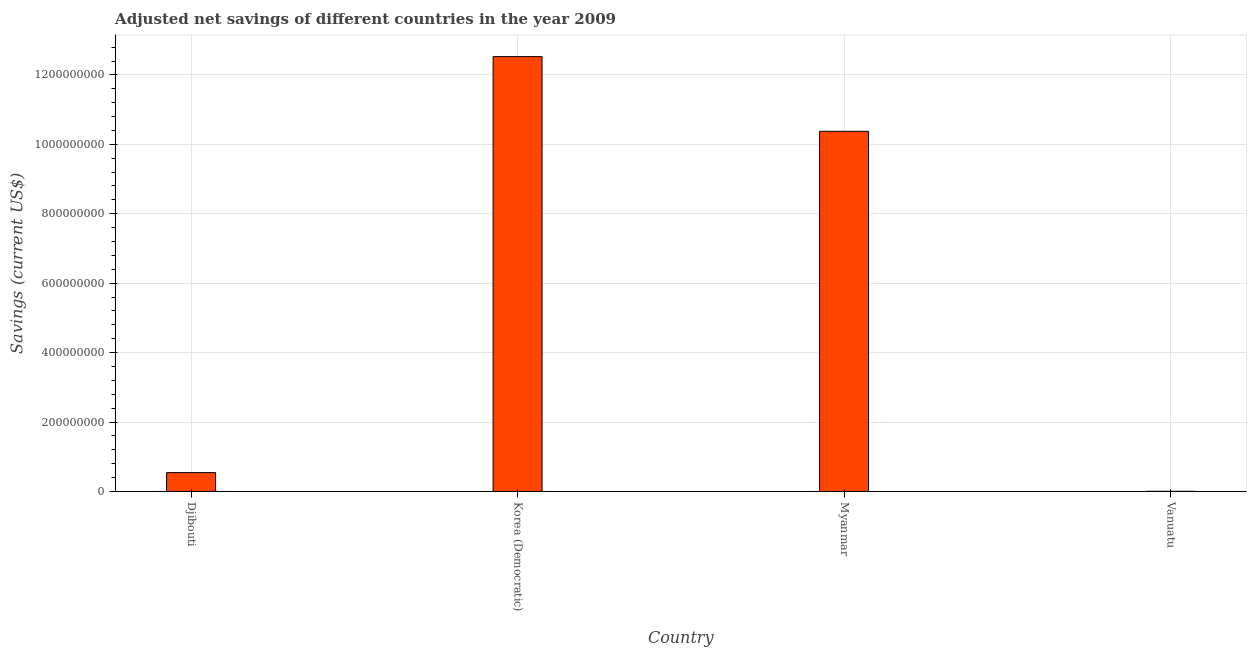Does the graph contain any zero values?
Ensure brevity in your answer.  No. What is the title of the graph?
Ensure brevity in your answer.  Adjusted net savings of different countries in the year 2009. What is the label or title of the Y-axis?
Give a very brief answer. Savings (current US$). What is the adjusted net savings in Vanuatu?
Your answer should be very brief. 5.18e+05. Across all countries, what is the maximum adjusted net savings?
Make the answer very short. 1.25e+09. Across all countries, what is the minimum adjusted net savings?
Offer a very short reply. 5.18e+05. In which country was the adjusted net savings maximum?
Provide a succinct answer. Korea (Democratic). In which country was the adjusted net savings minimum?
Offer a very short reply. Vanuatu. What is the sum of the adjusted net savings?
Make the answer very short. 2.35e+09. What is the difference between the adjusted net savings in Djibouti and Vanuatu?
Make the answer very short. 5.38e+07. What is the average adjusted net savings per country?
Give a very brief answer. 5.86e+08. What is the median adjusted net savings?
Your response must be concise. 5.46e+08. What is the ratio of the adjusted net savings in Korea (Democratic) to that in Myanmar?
Keep it short and to the point. 1.21. Is the difference between the adjusted net savings in Djibouti and Myanmar greater than the difference between any two countries?
Your response must be concise. No. What is the difference between the highest and the second highest adjusted net savings?
Make the answer very short. 2.15e+08. Is the sum of the adjusted net savings in Korea (Democratic) and Vanuatu greater than the maximum adjusted net savings across all countries?
Ensure brevity in your answer.  Yes. What is the difference between the highest and the lowest adjusted net savings?
Your response must be concise. 1.25e+09. How many bars are there?
Offer a very short reply. 4. Are all the bars in the graph horizontal?
Keep it short and to the point. No. How many countries are there in the graph?
Provide a succinct answer. 4. What is the difference between two consecutive major ticks on the Y-axis?
Keep it short and to the point. 2.00e+08. Are the values on the major ticks of Y-axis written in scientific E-notation?
Offer a very short reply. No. What is the Savings (current US$) in Djibouti?
Make the answer very short. 5.43e+07. What is the Savings (current US$) in Korea (Democratic)?
Offer a very short reply. 1.25e+09. What is the Savings (current US$) in Myanmar?
Offer a terse response. 1.04e+09. What is the Savings (current US$) in Vanuatu?
Make the answer very short. 5.18e+05. What is the difference between the Savings (current US$) in Djibouti and Korea (Democratic)?
Provide a succinct answer. -1.20e+09. What is the difference between the Savings (current US$) in Djibouti and Myanmar?
Offer a terse response. -9.83e+08. What is the difference between the Savings (current US$) in Djibouti and Vanuatu?
Give a very brief answer. 5.38e+07. What is the difference between the Savings (current US$) in Korea (Democratic) and Myanmar?
Offer a terse response. 2.15e+08. What is the difference between the Savings (current US$) in Korea (Democratic) and Vanuatu?
Ensure brevity in your answer.  1.25e+09. What is the difference between the Savings (current US$) in Myanmar and Vanuatu?
Ensure brevity in your answer.  1.04e+09. What is the ratio of the Savings (current US$) in Djibouti to that in Korea (Democratic)?
Your response must be concise. 0.04. What is the ratio of the Savings (current US$) in Djibouti to that in Myanmar?
Ensure brevity in your answer.  0.05. What is the ratio of the Savings (current US$) in Djibouti to that in Vanuatu?
Provide a succinct answer. 104.81. What is the ratio of the Savings (current US$) in Korea (Democratic) to that in Myanmar?
Your answer should be compact. 1.21. What is the ratio of the Savings (current US$) in Korea (Democratic) to that in Vanuatu?
Offer a very short reply. 2417.55. What is the ratio of the Savings (current US$) in Myanmar to that in Vanuatu?
Offer a terse response. 2002.34. 